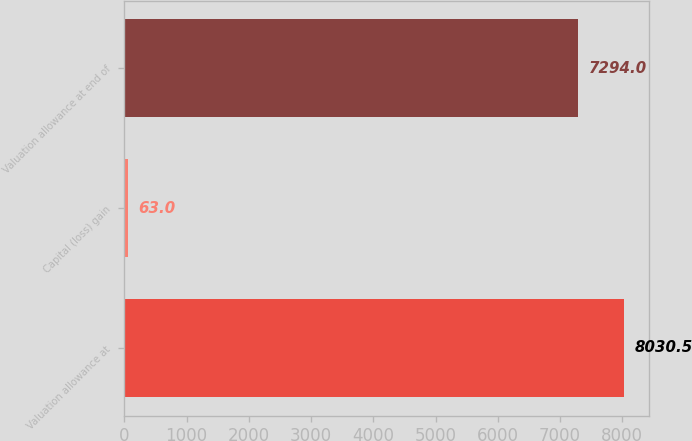Convert chart to OTSL. <chart><loc_0><loc_0><loc_500><loc_500><bar_chart><fcel>Valuation allowance at<fcel>Capital (loss) gain<fcel>Valuation allowance at end of<nl><fcel>8030.5<fcel>63<fcel>7294<nl></chart> 